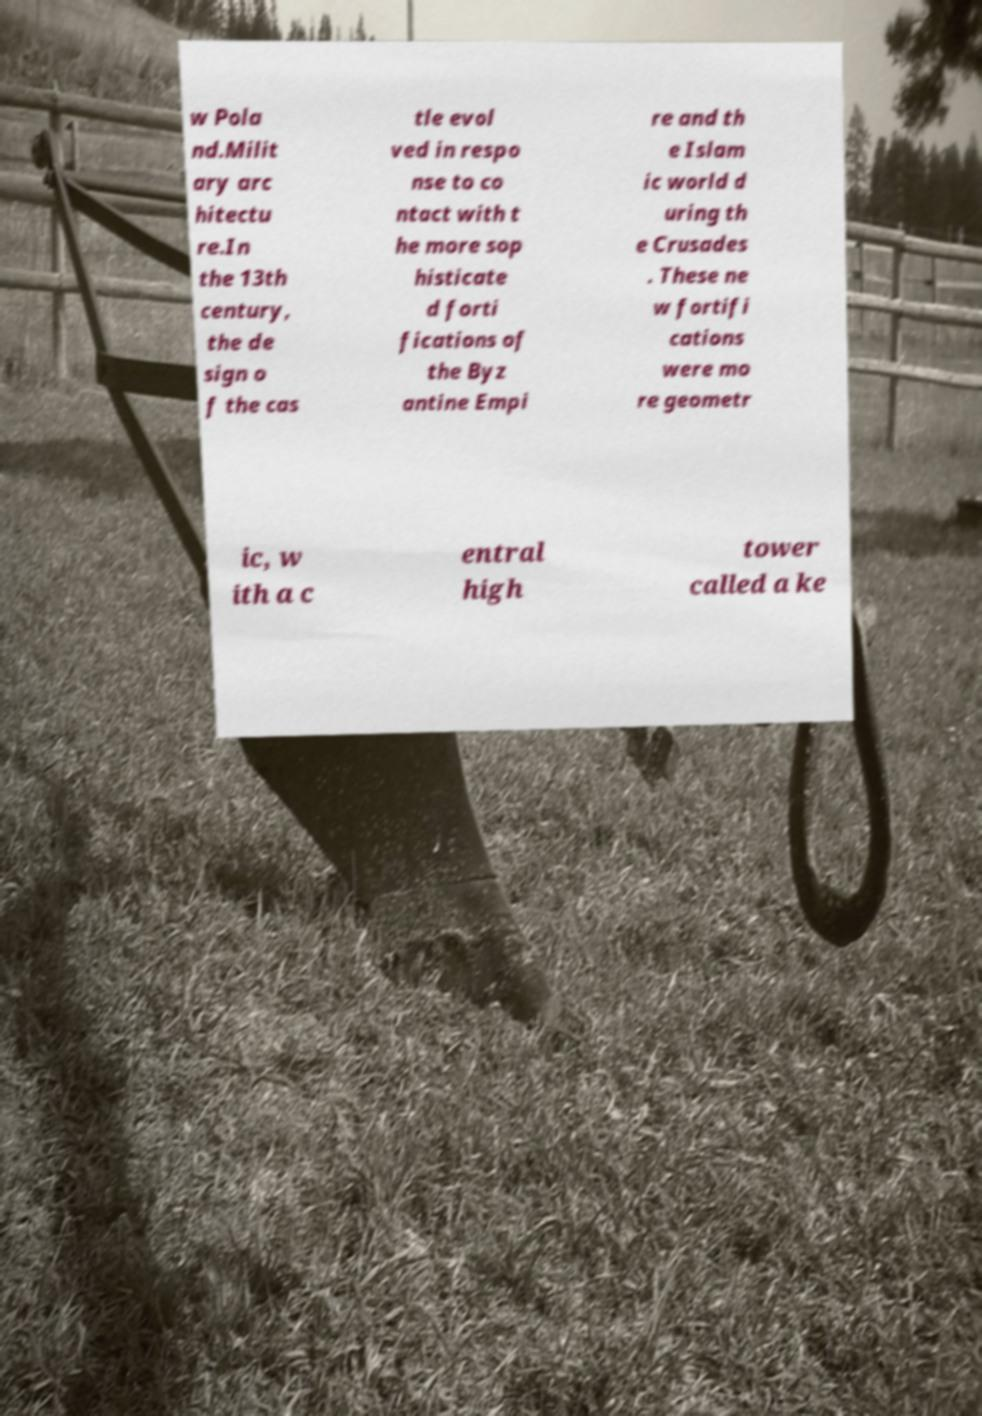Can you read and provide the text displayed in the image?This photo seems to have some interesting text. Can you extract and type it out for me? w Pola nd.Milit ary arc hitectu re.In the 13th century, the de sign o f the cas tle evol ved in respo nse to co ntact with t he more sop histicate d forti fications of the Byz antine Empi re and th e Islam ic world d uring th e Crusades . These ne w fortifi cations were mo re geometr ic, w ith a c entral high tower called a ke 